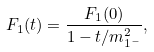Convert formula to latex. <formula><loc_0><loc_0><loc_500><loc_500>F _ { 1 } ( t ) = \frac { F _ { 1 } ( 0 ) } { 1 - t / m _ { 1 ^ { - } } ^ { 2 } } ,</formula> 